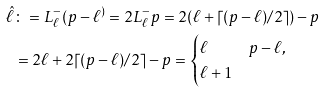<formula> <loc_0><loc_0><loc_500><loc_500>\hat { \ell } & \colon = L _ { \ell } ^ { - } ( p - \ell ^ { ) } = 2 L _ { \ell } ^ { - } p = 2 ( \ell + \lceil ( p - \ell ) / 2 \rceil ) - p \\ & = 2 \ell + 2 \lceil ( p - \ell ) / 2 \rceil - p = \begin{cases} \ell & p - \ell , \\ \ell + 1 & \end{cases}</formula> 